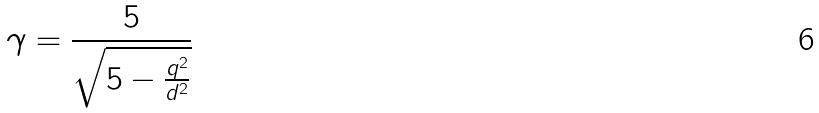<formula> <loc_0><loc_0><loc_500><loc_500>\gamma = \frac { 5 } { \sqrt { 5 - \frac { q ^ { 2 } } { d ^ { 2 } } } }</formula> 